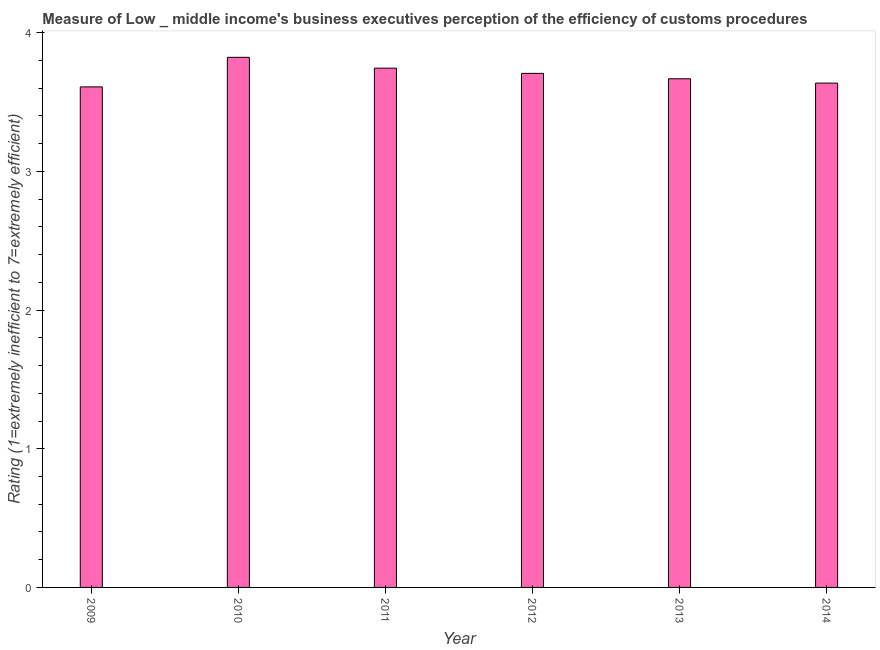What is the title of the graph?
Ensure brevity in your answer.  Measure of Low _ middle income's business executives perception of the efficiency of customs procedures. What is the label or title of the X-axis?
Ensure brevity in your answer.  Year. What is the label or title of the Y-axis?
Offer a very short reply. Rating (1=extremely inefficient to 7=extremely efficient). What is the rating measuring burden of customs procedure in 2009?
Your answer should be very brief. 3.61. Across all years, what is the maximum rating measuring burden of customs procedure?
Give a very brief answer. 3.82. Across all years, what is the minimum rating measuring burden of customs procedure?
Your answer should be very brief. 3.61. What is the sum of the rating measuring burden of customs procedure?
Offer a very short reply. 22.19. What is the difference between the rating measuring burden of customs procedure in 2009 and 2011?
Your answer should be very brief. -0.14. What is the average rating measuring burden of customs procedure per year?
Offer a terse response. 3.7. What is the median rating measuring burden of customs procedure?
Your response must be concise. 3.69. Do a majority of the years between 2014 and 2011 (inclusive) have rating measuring burden of customs procedure greater than 3.4 ?
Provide a succinct answer. Yes. What is the ratio of the rating measuring burden of customs procedure in 2010 to that in 2012?
Your response must be concise. 1.03. Is the rating measuring burden of customs procedure in 2010 less than that in 2013?
Give a very brief answer. No. What is the difference between the highest and the second highest rating measuring burden of customs procedure?
Keep it short and to the point. 0.08. Is the sum of the rating measuring burden of customs procedure in 2012 and 2013 greater than the maximum rating measuring burden of customs procedure across all years?
Provide a short and direct response. Yes. What is the difference between the highest and the lowest rating measuring burden of customs procedure?
Offer a very short reply. 0.21. In how many years, is the rating measuring burden of customs procedure greater than the average rating measuring burden of customs procedure taken over all years?
Make the answer very short. 3. What is the difference between two consecutive major ticks on the Y-axis?
Offer a very short reply. 1. Are the values on the major ticks of Y-axis written in scientific E-notation?
Make the answer very short. No. What is the Rating (1=extremely inefficient to 7=extremely efficient) in 2009?
Your answer should be compact. 3.61. What is the Rating (1=extremely inefficient to 7=extremely efficient) of 2010?
Your answer should be compact. 3.82. What is the Rating (1=extremely inefficient to 7=extremely efficient) in 2011?
Your response must be concise. 3.74. What is the Rating (1=extremely inefficient to 7=extremely efficient) in 2012?
Your answer should be compact. 3.71. What is the Rating (1=extremely inefficient to 7=extremely efficient) in 2013?
Provide a short and direct response. 3.67. What is the Rating (1=extremely inefficient to 7=extremely efficient) of 2014?
Offer a terse response. 3.64. What is the difference between the Rating (1=extremely inefficient to 7=extremely efficient) in 2009 and 2010?
Give a very brief answer. -0.21. What is the difference between the Rating (1=extremely inefficient to 7=extremely efficient) in 2009 and 2011?
Keep it short and to the point. -0.14. What is the difference between the Rating (1=extremely inefficient to 7=extremely efficient) in 2009 and 2012?
Your response must be concise. -0.1. What is the difference between the Rating (1=extremely inefficient to 7=extremely efficient) in 2009 and 2013?
Give a very brief answer. -0.06. What is the difference between the Rating (1=extremely inefficient to 7=extremely efficient) in 2009 and 2014?
Offer a terse response. -0.03. What is the difference between the Rating (1=extremely inefficient to 7=extremely efficient) in 2010 and 2011?
Keep it short and to the point. 0.08. What is the difference between the Rating (1=extremely inefficient to 7=extremely efficient) in 2010 and 2012?
Your response must be concise. 0.12. What is the difference between the Rating (1=extremely inefficient to 7=extremely efficient) in 2010 and 2013?
Your response must be concise. 0.15. What is the difference between the Rating (1=extremely inefficient to 7=extremely efficient) in 2010 and 2014?
Make the answer very short. 0.19. What is the difference between the Rating (1=extremely inefficient to 7=extremely efficient) in 2011 and 2012?
Your response must be concise. 0.04. What is the difference between the Rating (1=extremely inefficient to 7=extremely efficient) in 2011 and 2013?
Provide a succinct answer. 0.08. What is the difference between the Rating (1=extremely inefficient to 7=extremely efficient) in 2011 and 2014?
Offer a very short reply. 0.11. What is the difference between the Rating (1=extremely inefficient to 7=extremely efficient) in 2012 and 2013?
Provide a short and direct response. 0.04. What is the difference between the Rating (1=extremely inefficient to 7=extremely efficient) in 2012 and 2014?
Your answer should be compact. 0.07. What is the difference between the Rating (1=extremely inefficient to 7=extremely efficient) in 2013 and 2014?
Your answer should be compact. 0.03. What is the ratio of the Rating (1=extremely inefficient to 7=extremely efficient) in 2009 to that in 2010?
Keep it short and to the point. 0.94. What is the ratio of the Rating (1=extremely inefficient to 7=extremely efficient) in 2010 to that in 2012?
Offer a terse response. 1.03. What is the ratio of the Rating (1=extremely inefficient to 7=extremely efficient) in 2010 to that in 2013?
Provide a succinct answer. 1.04. What is the ratio of the Rating (1=extremely inefficient to 7=extremely efficient) in 2010 to that in 2014?
Offer a terse response. 1.05. What is the ratio of the Rating (1=extremely inefficient to 7=extremely efficient) in 2012 to that in 2014?
Your response must be concise. 1.02. What is the ratio of the Rating (1=extremely inefficient to 7=extremely efficient) in 2013 to that in 2014?
Offer a very short reply. 1.01. 